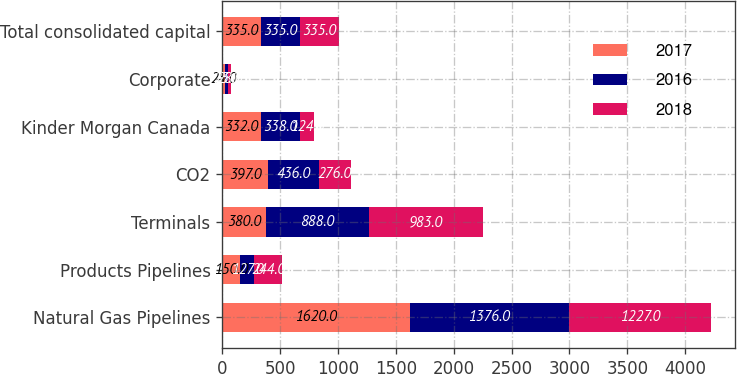<chart> <loc_0><loc_0><loc_500><loc_500><stacked_bar_chart><ecel><fcel>Natural Gas Pipelines<fcel>Products Pipelines<fcel>Terminals<fcel>CO2<fcel>Kinder Morgan Canada<fcel>Corporate<fcel>Total consolidated capital<nl><fcel>2017<fcel>1620<fcel>150<fcel>380<fcel>397<fcel>332<fcel>25<fcel>335<nl><fcel>2016<fcel>1376<fcel>127<fcel>888<fcel>436<fcel>338<fcel>23<fcel>335<nl><fcel>2018<fcel>1227<fcel>244<fcel>983<fcel>276<fcel>124<fcel>28<fcel>335<nl></chart> 